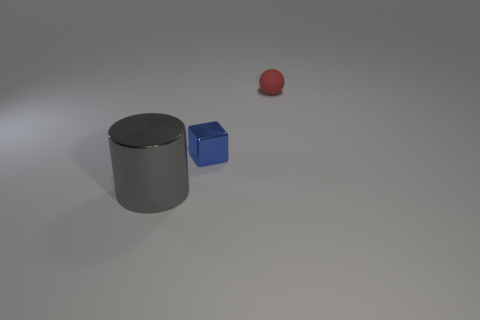Add 3 large shiny objects. How many objects exist? 6 Subtract all blocks. How many objects are left? 2 Subtract 0 cyan cylinders. How many objects are left? 3 Subtract all matte balls. Subtract all red objects. How many objects are left? 1 Add 3 metal cubes. How many metal cubes are left? 4 Add 2 small yellow cylinders. How many small yellow cylinders exist? 2 